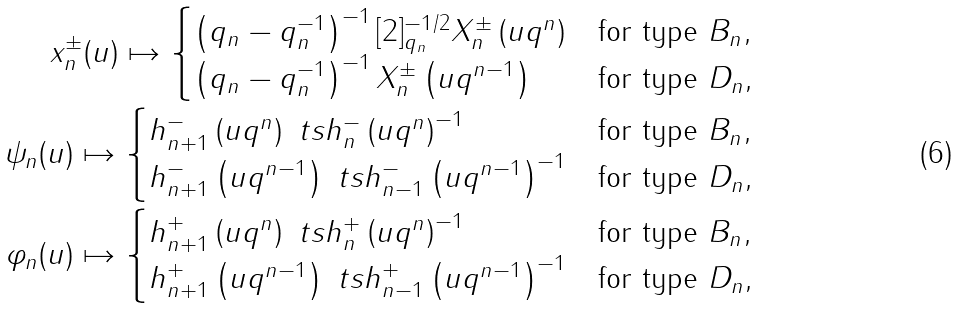Convert formula to latex. <formula><loc_0><loc_0><loc_500><loc_500>x ^ { \pm } _ { n } ( u ) \mapsto \begin{cases} \left ( q _ { n } - q _ { n } ^ { - 1 } \right ) ^ { - 1 } [ 2 ] _ { q _ { n } } ^ { - 1 / 2 } X ^ { \pm } _ { n } \left ( u q ^ { n } \right ) & \text {for type $B_{n}$} , \\ \left ( q _ { n } - q _ { n } ^ { - 1 } \right ) ^ { - 1 } X ^ { \pm } _ { n } \left ( u q ^ { n - 1 } \right ) & \text {for type $D_{n}$} , \end{cases} \\ \psi _ { n } ( u ) \mapsto \begin{cases} h ^ { - } _ { n + 1 } \left ( u q ^ { n } \right ) \ t s h ^ { - } _ { n } \left ( u q ^ { n } \right ) ^ { - 1 } & \text {for type $B_{n}$} , \\ h ^ { - } _ { n + 1 } \left ( u q ^ { n - 1 } \right ) \ t s h ^ { - } _ { n - 1 } \left ( u q ^ { n - 1 } \right ) ^ { - 1 } & \text {for type $D_{n}$} , \end{cases} \\ \varphi _ { n } ( u ) \mapsto \begin{cases} h ^ { + } _ { n + 1 } \left ( u q ^ { n } \right ) \ t s h ^ { + } _ { n } \left ( u q ^ { n } \right ) ^ { - 1 } & \text {for type $B_{n}$} , \\ h ^ { + } _ { n + 1 } \left ( u q ^ { n - 1 } \right ) \ t s h ^ { + } _ { n - 1 } \left ( u q ^ { n - 1 } \right ) ^ { - 1 } & \text {for type $D_{n}$} , \end{cases}</formula> 